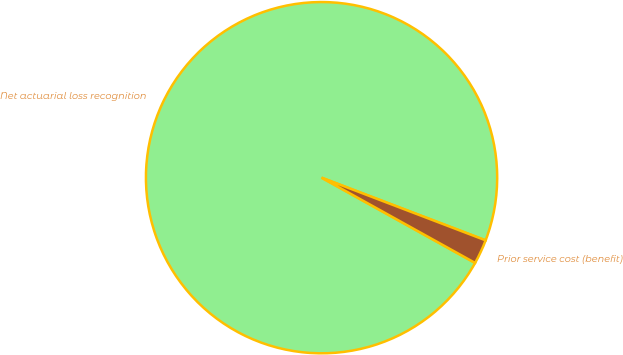Convert chart. <chart><loc_0><loc_0><loc_500><loc_500><pie_chart><fcel>Net actuarial loss recognition<fcel>Prior service cost (benefit)<nl><fcel>97.74%<fcel>2.26%<nl></chart> 